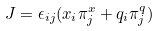<formula> <loc_0><loc_0><loc_500><loc_500>J = \epsilon _ { i j } ( x _ { i } \pi _ { j } ^ { x } + q _ { i } \pi _ { j } ^ { q } )</formula> 